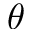<formula> <loc_0><loc_0><loc_500><loc_500>\theta</formula> 